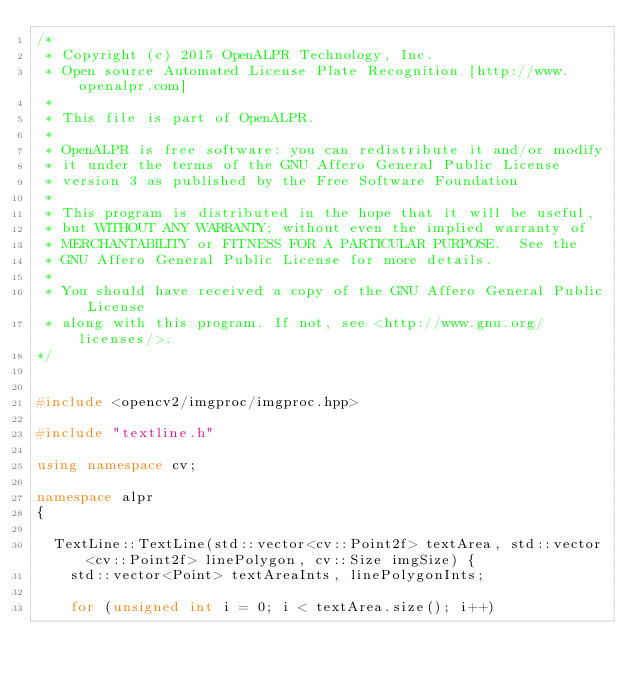<code> <loc_0><loc_0><loc_500><loc_500><_C++_>/*
 * Copyright (c) 2015 OpenALPR Technology, Inc.
 * Open source Automated License Plate Recognition [http://www.openalpr.com]
 *
 * This file is part of OpenALPR.
 *
 * OpenALPR is free software: you can redistribute it and/or modify
 * it under the terms of the GNU Affero General Public License
 * version 3 as published by the Free Software Foundation
 *
 * This program is distributed in the hope that it will be useful,
 * but WITHOUT ANY WARRANTY; without even the implied warranty of
 * MERCHANTABILITY or FITNESS FOR A PARTICULAR PURPOSE.  See the
 * GNU Affero General Public License for more details.
 *
 * You should have received a copy of the GNU Affero General Public License
 * along with this program. If not, see <http://www.gnu.org/licenses/>.
*/


#include <opencv2/imgproc/imgproc.hpp>

#include "textline.h"

using namespace cv;

namespace alpr
{

  TextLine::TextLine(std::vector<cv::Point2f> textArea, std::vector<cv::Point2f> linePolygon, cv::Size imgSize) {
    std::vector<Point> textAreaInts, linePolygonInts;

    for (unsigned int i = 0; i < textArea.size(); i++)</code> 